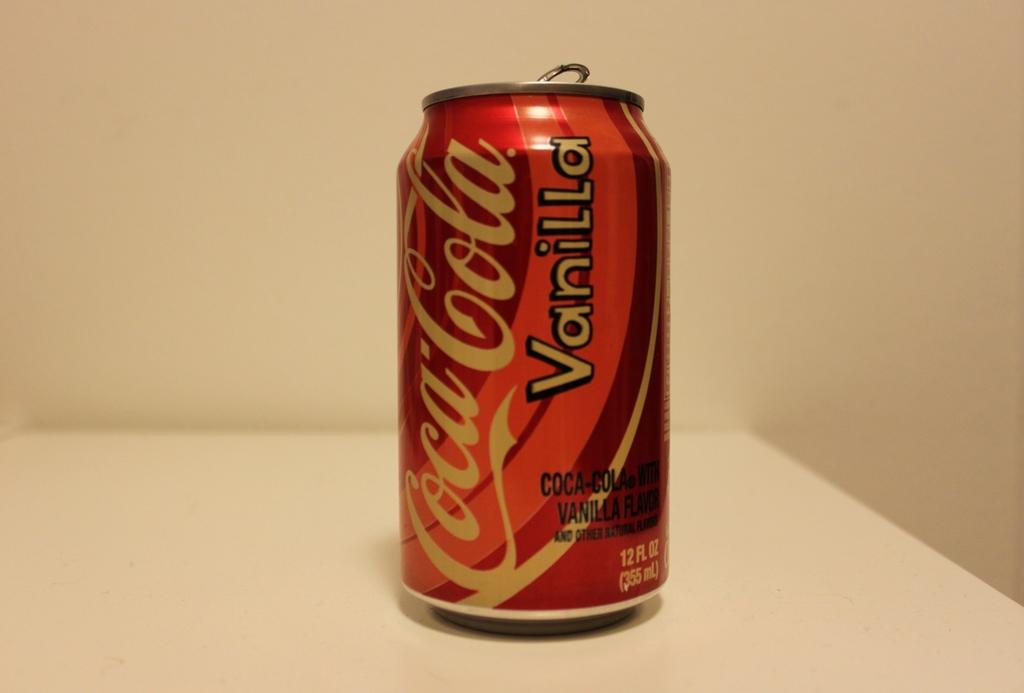Provide a one-sentence caption for the provided image. A 12 oz can of vanilla coca cola. 